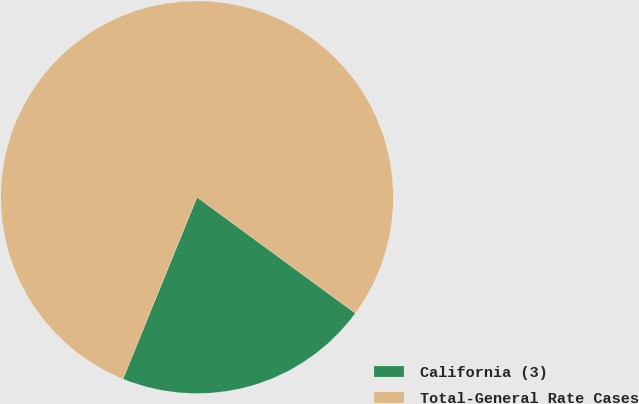<chart> <loc_0><loc_0><loc_500><loc_500><pie_chart><fcel>California (3)<fcel>Total-General Rate Cases<nl><fcel>21.09%<fcel>78.91%<nl></chart> 